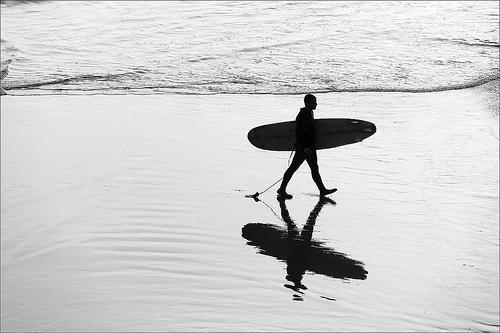How many shadows are in the photograph?
Give a very brief answer. 1. How many surfers are in the picture?
Give a very brief answer. 1. How many thirds of the photograph contain the ocean?
Give a very brief answer. 1. 